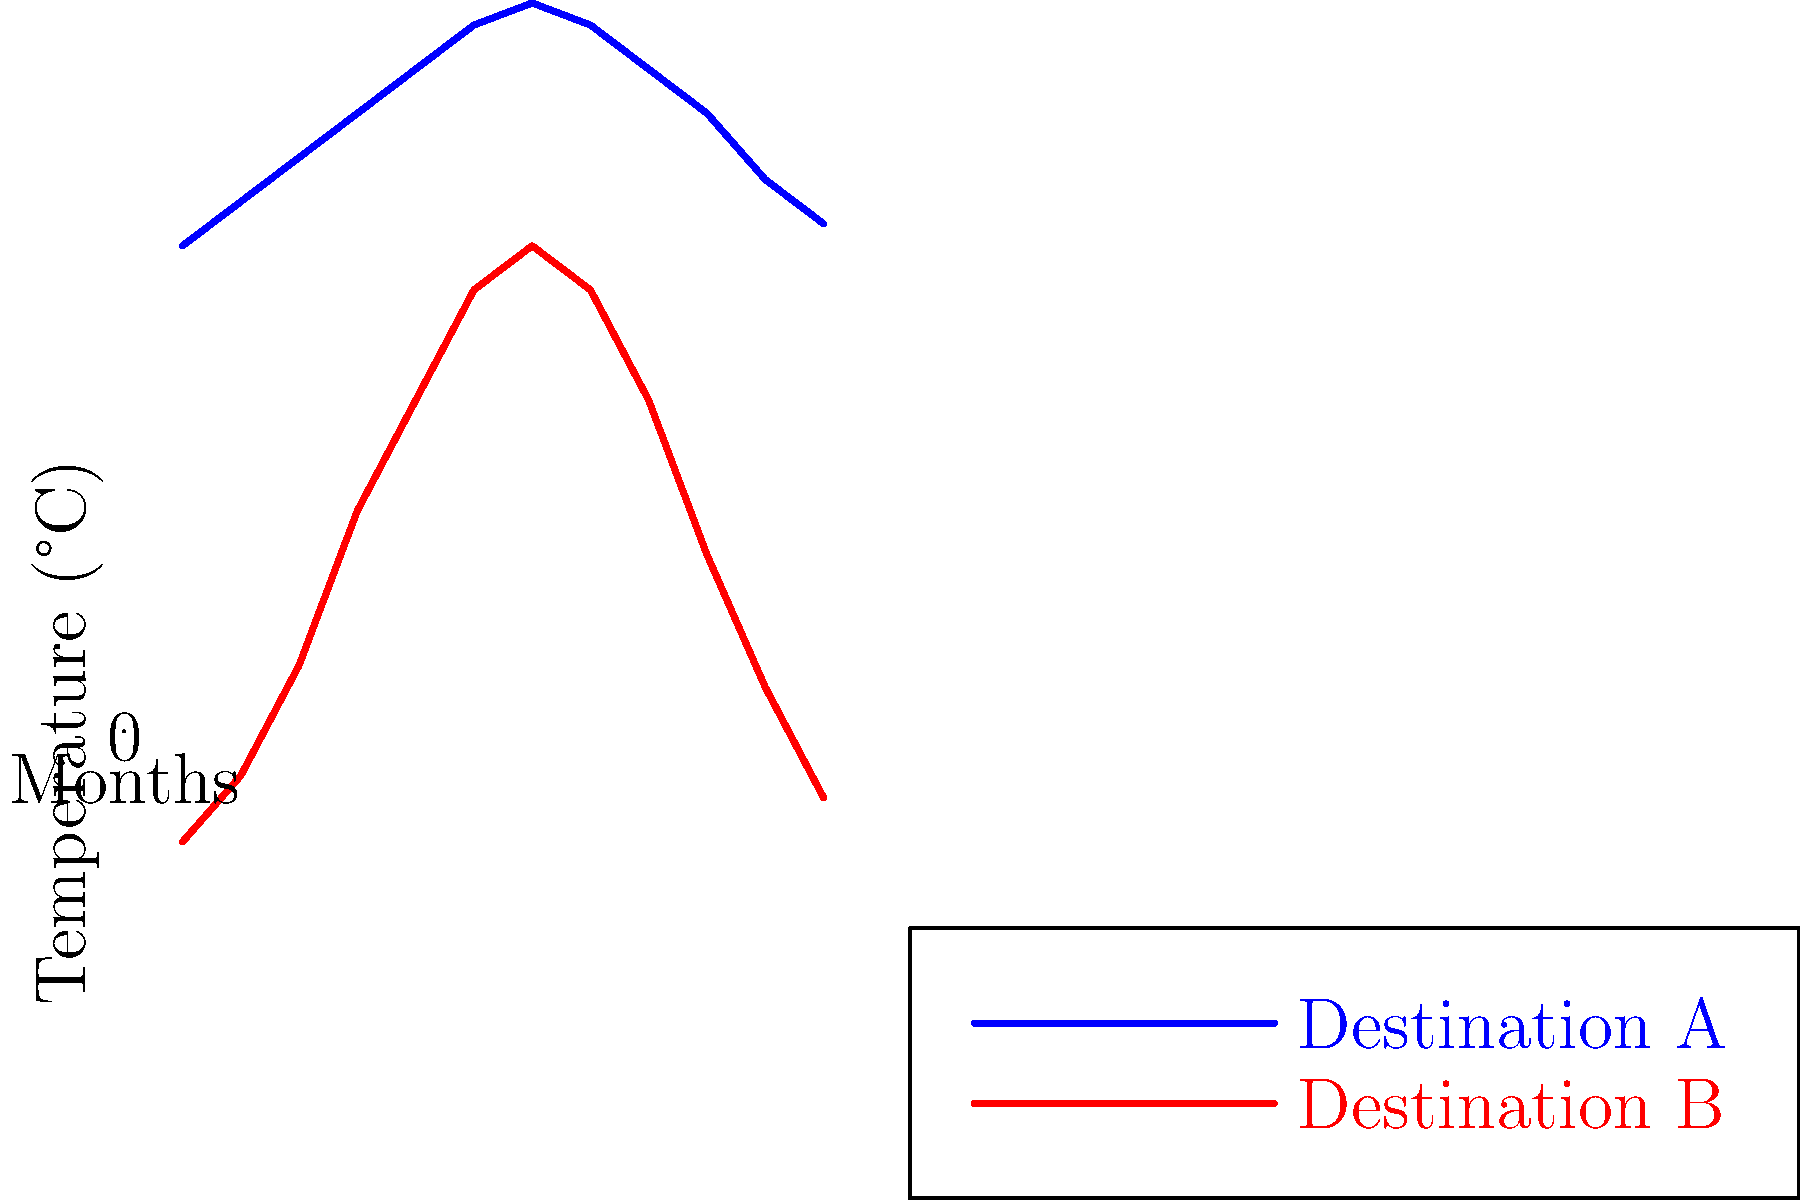As a travel guide narrator, analyze the temperature patterns of Destinations A and B shown in the line graph. Which destination would you recommend for a traveler seeking a more stable climate throughout the year, and why? To determine which destination has a more stable climate, we need to analyze the temperature variations throughout the year for both destinations:

1. Destination A:
   - Minimum temperature: approximately 22°C (Month 1)
   - Maximum temperature: approximately 33°C (Month 7)
   - Temperature range: 33°C - 22°C = 11°C

2. Destination B:
   - Minimum temperature: approximately -5°C (Month 1)
   - Maximum temperature: approximately 22°C (Month 7)
   - Temperature range: 22°C - (-5°C) = 27°C

3. Compare the temperature ranges:
   - Destination A has a range of 11°C
   - Destination B has a range of 27°C

4. Analyze the graph patterns:
   - Destination A shows a gradual increase and decrease in temperature throughout the year
   - Destination B displays more dramatic temperature changes between seasons

5. Consider climate stability:
   - A smaller temperature range indicates a more stable climate
   - Gradual temperature changes also contribute to climate stability

Based on this analysis, Destination A has a more stable climate throughout the year due to its smaller temperature range (11°C vs. 27°C) and more gradual temperature changes. This makes Destination A more suitable for travelers seeking a consistent climate experience.
Answer: Destination A, due to its smaller temperature range (11°C) and gradual temperature changes. 